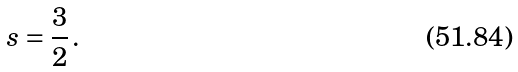<formula> <loc_0><loc_0><loc_500><loc_500>s = \frac { 3 } { 2 } \, .</formula> 